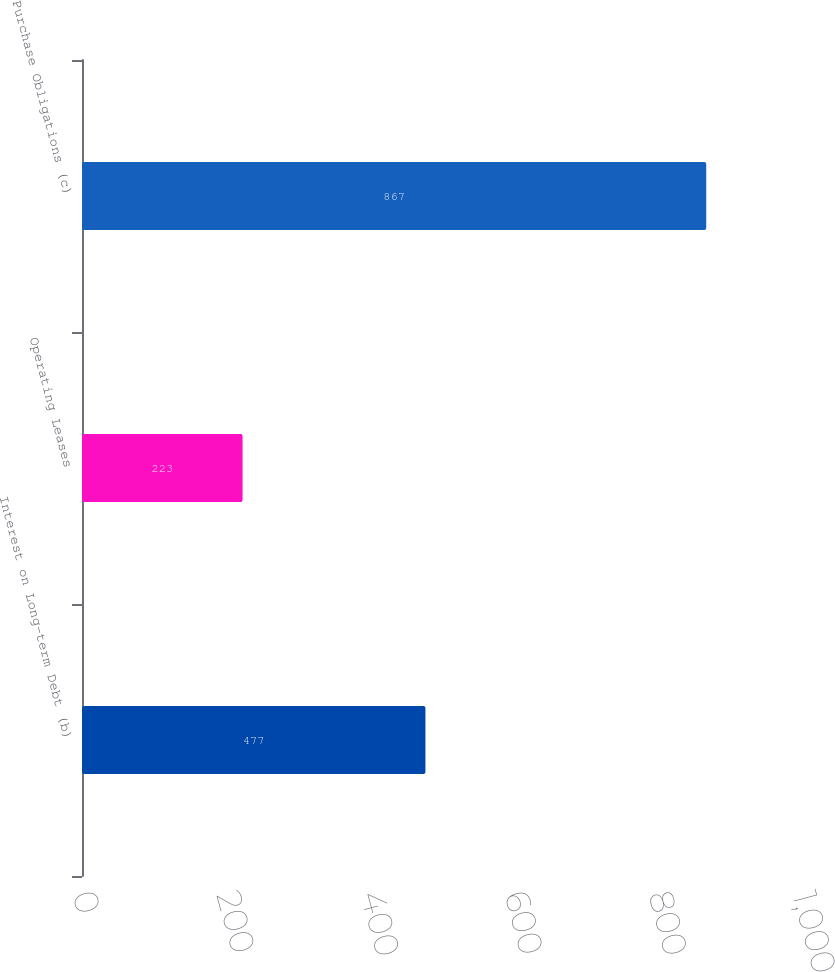Convert chart to OTSL. <chart><loc_0><loc_0><loc_500><loc_500><bar_chart><fcel>Interest on Long-term Debt (b)<fcel>Operating Leases<fcel>Purchase Obligations (c)<nl><fcel>477<fcel>223<fcel>867<nl></chart> 